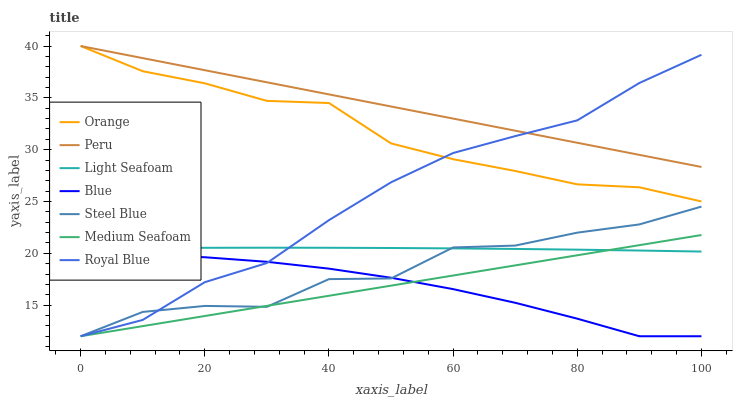Does Steel Blue have the minimum area under the curve?
Answer yes or no. No. Does Steel Blue have the maximum area under the curve?
Answer yes or no. No. Is Royal Blue the smoothest?
Answer yes or no. No. Is Royal Blue the roughest?
Answer yes or no. No. Does Peru have the lowest value?
Answer yes or no. No. Does Steel Blue have the highest value?
Answer yes or no. No. Is Light Seafoam less than Orange?
Answer yes or no. Yes. Is Peru greater than Light Seafoam?
Answer yes or no. Yes. Does Light Seafoam intersect Orange?
Answer yes or no. No. 